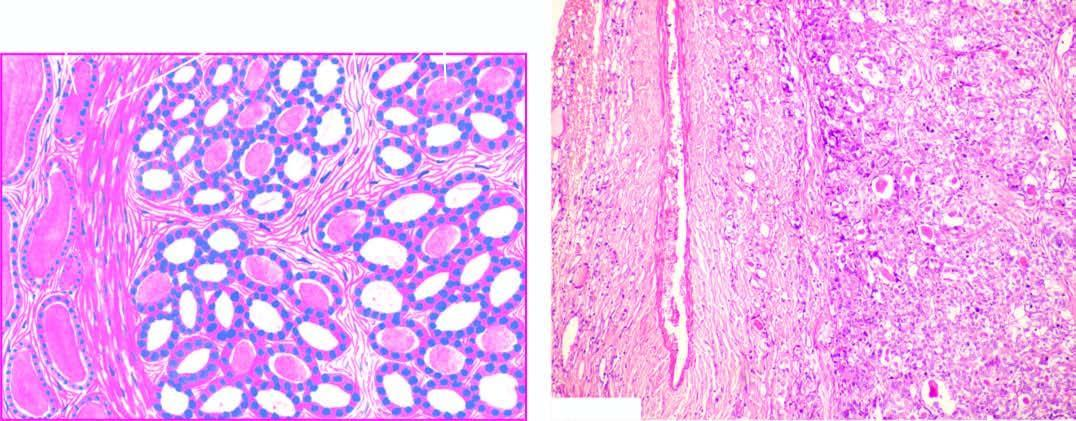what consists of small follicles lined by cuboidal epithelium and contain little or no colloid and separated by abundant loose stroma?
Answer the question using a single word or phrase. Tumour 